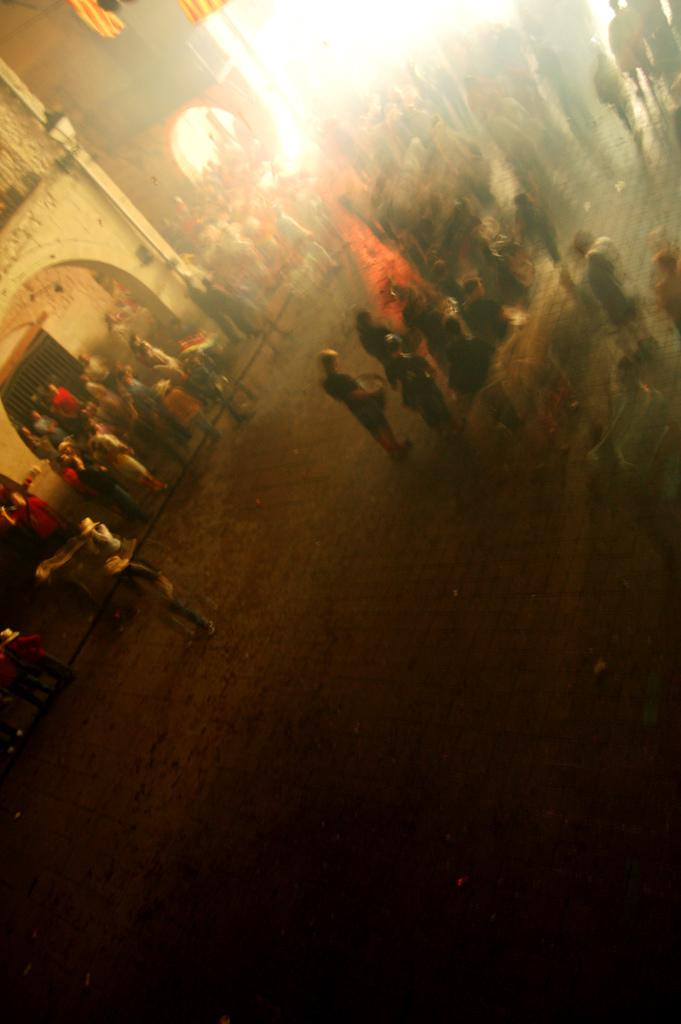Where are the persons standing in the image? Some persons are standing on the floor, while others are standing on the pavement. What can be seen in the background of the image? There are buildings in the background. What is visible at the top of the image? Flags are visible at the top of the image. How many nests can be seen in the image? There are no nests present in the image. What type of bubble is floating near the persons in the image? There is no bubble present in the image. 